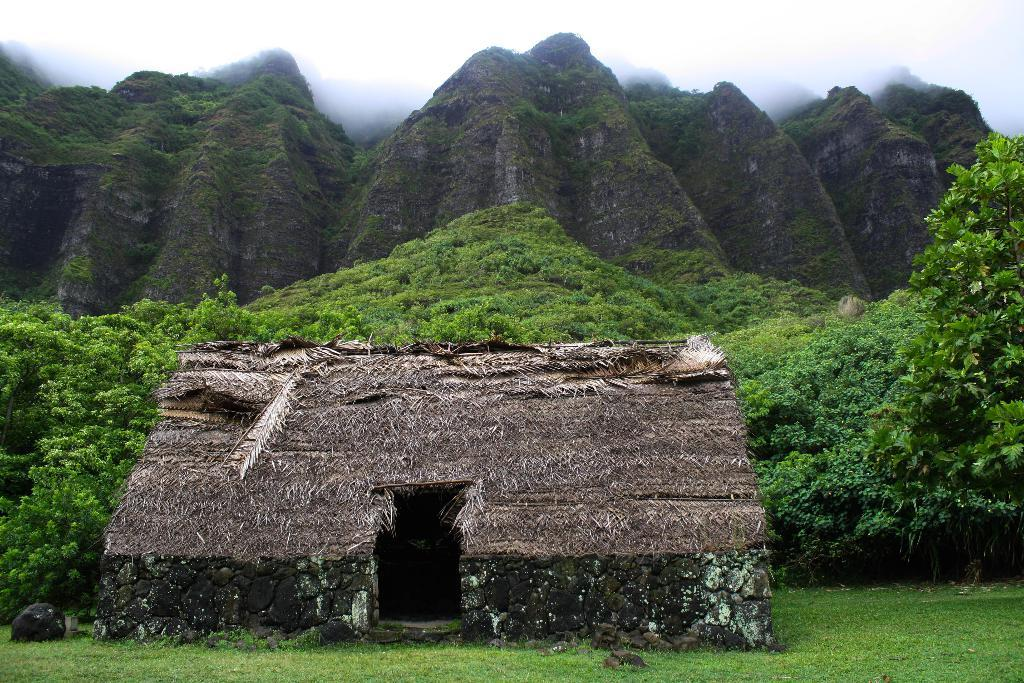What type of structure is in the image? There is a hut in the image. Where is the hut located? The hut is on the ground. What can be seen in the background of the image? There are trees, mountains, and the sky visible in the background of the image. What type of cap is the hut wearing in the image? There is no cap present in the image, as the hut is a structure and not a person. 